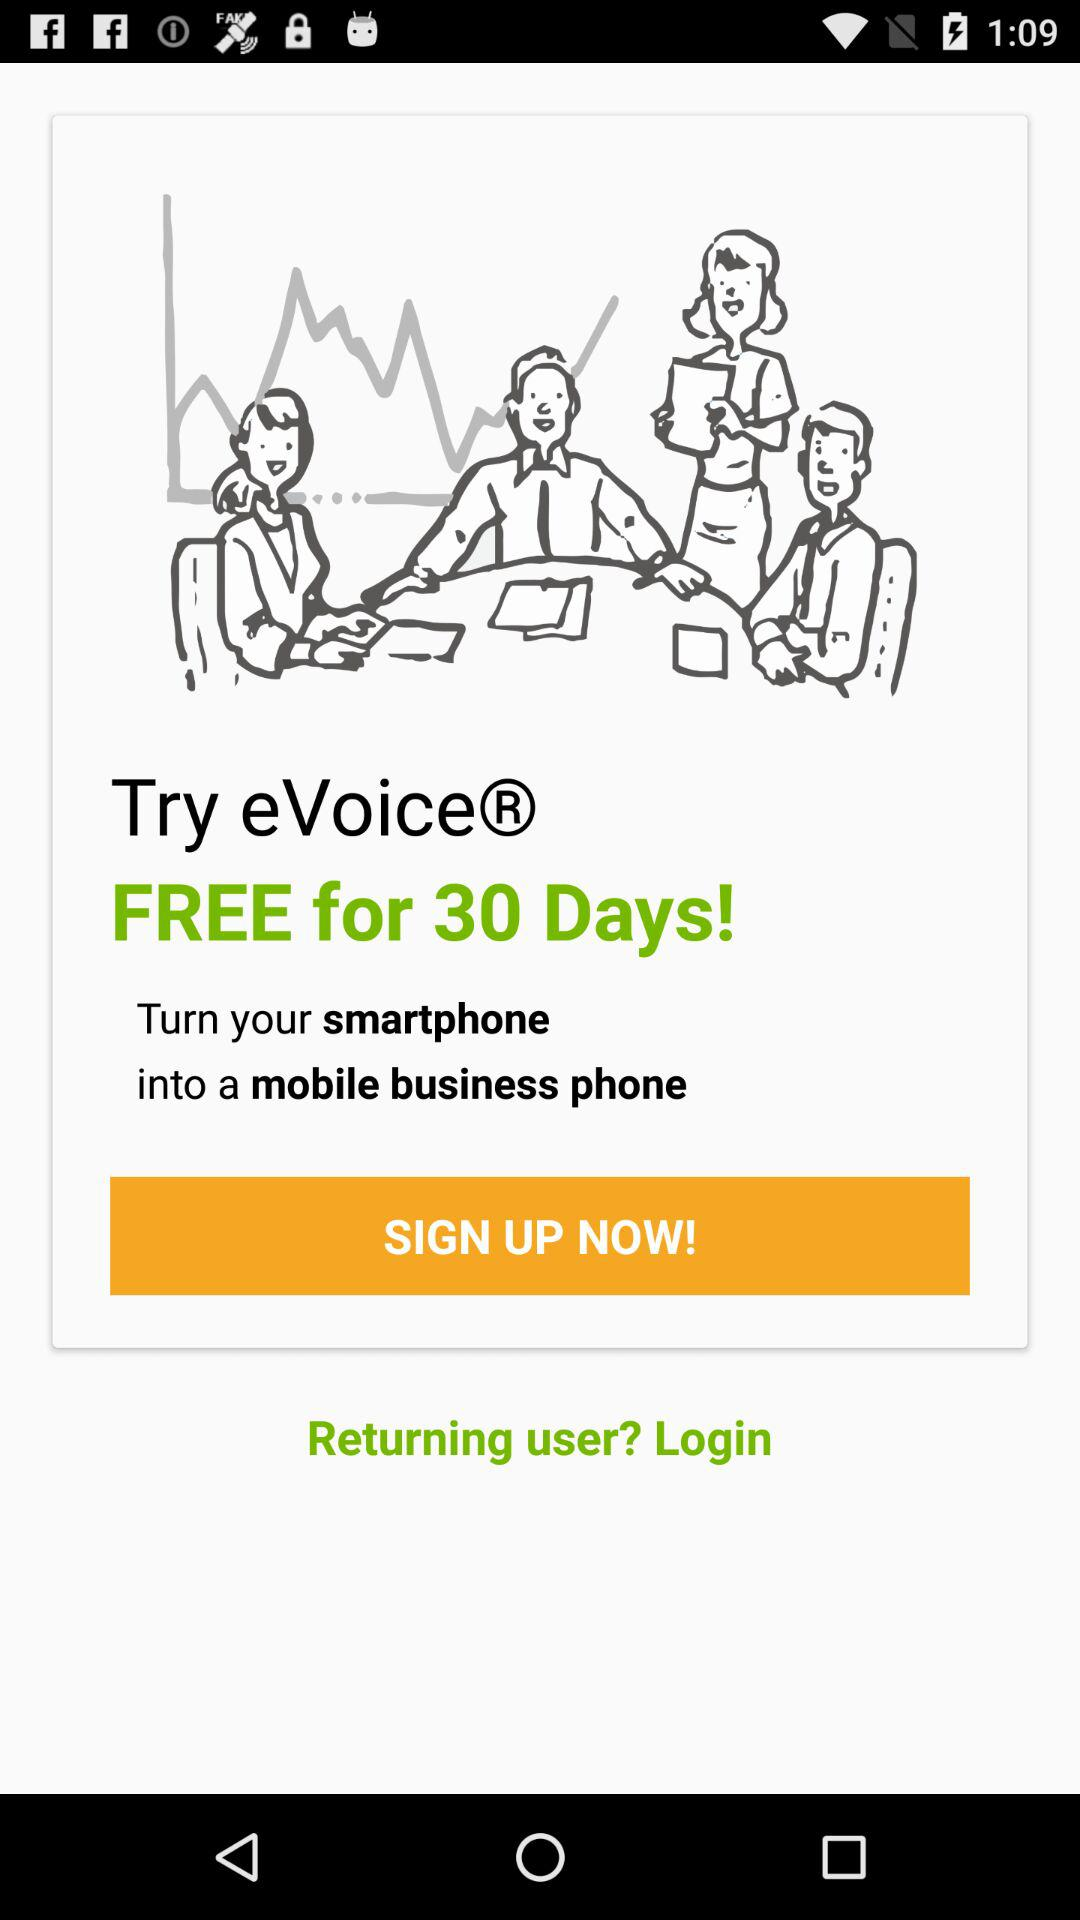For how many days is it free? It is free for 30 days. 